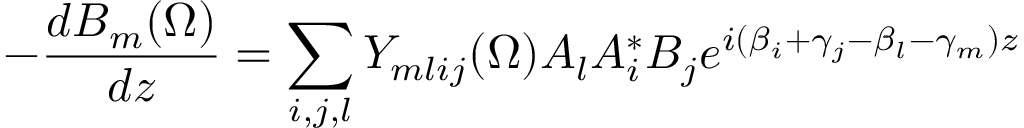Convert formula to latex. <formula><loc_0><loc_0><loc_500><loc_500>- \frac { d B _ { m } ( \Omega ) } { d z } = \sum _ { i , j , l } Y _ { m l i j } ( \Omega ) A _ { l } A _ { i } ^ { * } B _ { j } e ^ { i ( \beta _ { i } + \gamma _ { j } - \beta _ { l } - \gamma _ { m } ) z }</formula> 